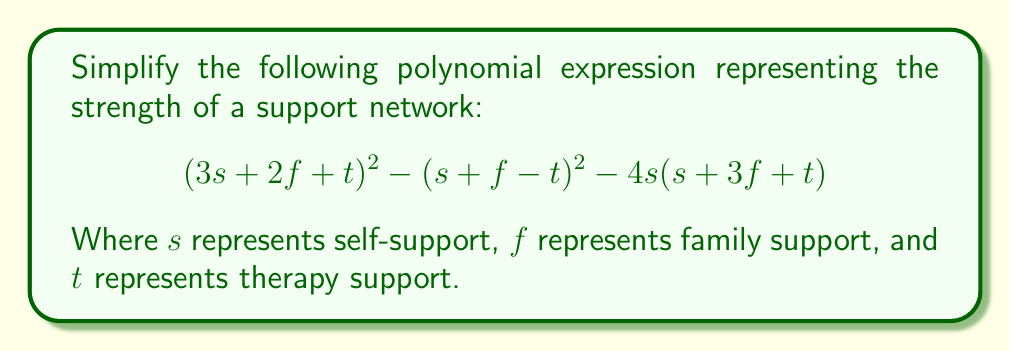What is the answer to this math problem? Let's approach this step-by-step:

1) First, let's expand $(3s + 2f + t)^2$:
   $$(3s + 2f + t)^2 = 9s^2 + 12sf + 6st + 4f^2 + 4ft + t^2$$

2) Next, let's expand $(s + f - t)^2$:
   $$(s + f - t)^2 = s^2 + 2sf + f^2 - 2st - 2ft + t^2$$

3) Now, let's expand $4s(s + 3f + t)$:
   $$4s(s + 3f + t) = 4s^2 + 12sf + 4st$$

4) Let's substitute these expansions back into the original expression:
   $$(9s^2 + 12sf + 6st + 4f^2 + 4ft + t^2) - (s^2 + 2sf + f^2 - 2st - 2ft + t^2) - (4s^2 + 12sf + 4st)$$

5) Now, let's group like terms:
   $$9s^2 + 12sf + 6st + 4f^2 + 4ft + t^2 - s^2 - 2sf - f^2 + 2st + 2ft - t^2 - 4s^2 - 12sf - 4st$$

6) Simplify:
   $$4s^2 - 2sf + 4st + 3f^2 + 6ft$$

This simplified expression represents the net strength of the support network, taking into account the interactions between different forms of support.
Answer: $$4s^2 - 2sf + 4st + 3f^2 + 6ft$$ 